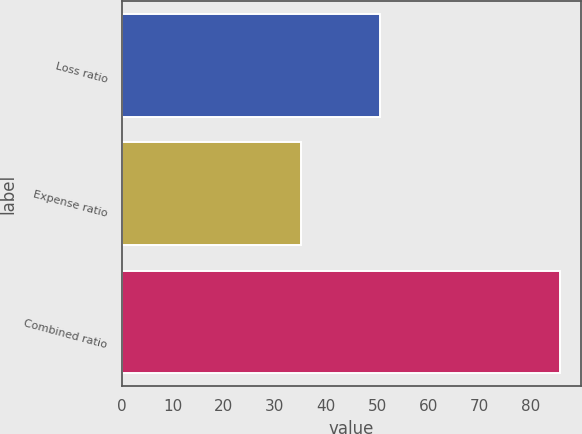Convert chart. <chart><loc_0><loc_0><loc_500><loc_500><bar_chart><fcel>Loss ratio<fcel>Expense ratio<fcel>Combined ratio<nl><fcel>50.6<fcel>35.1<fcel>85.7<nl></chart> 